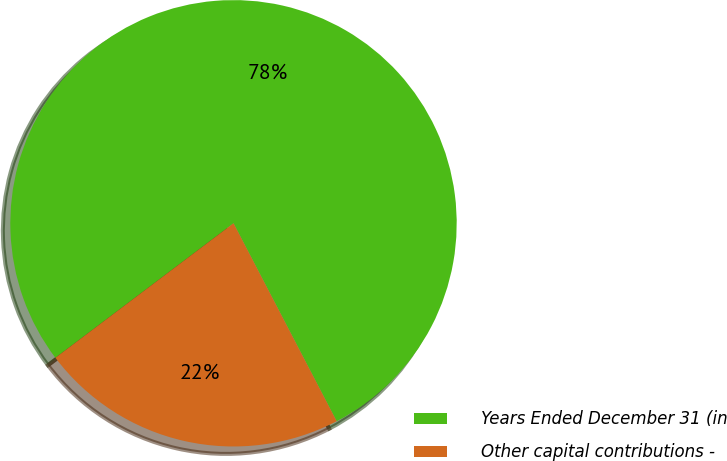Convert chart. <chart><loc_0><loc_0><loc_500><loc_500><pie_chart><fcel>Years Ended December 31 (in<fcel>Other capital contributions -<nl><fcel>77.65%<fcel>22.35%<nl></chart> 